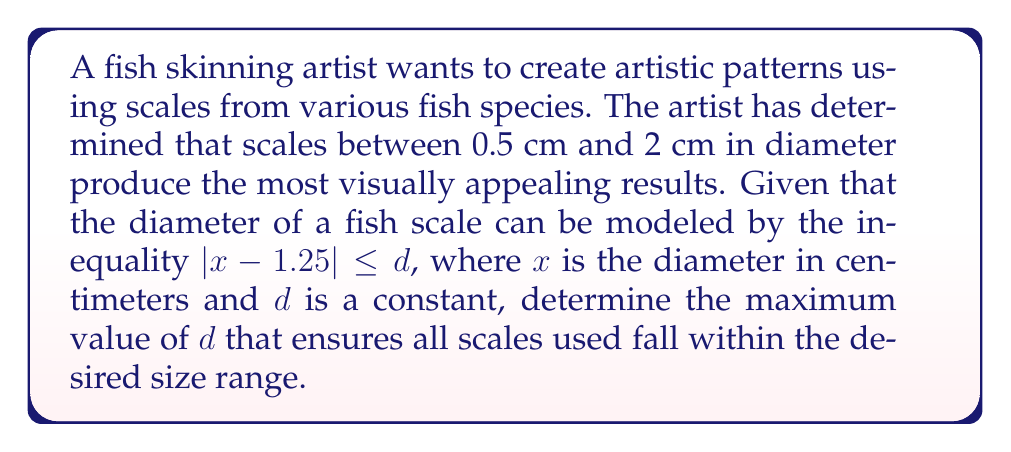Help me with this question. 1. The given inequality is $|x - 1.25| \leq d$, where $x$ is the diameter of the scale in cm.

2. The desired range for the scale diameter is between 0.5 cm and 2 cm, so:
   $0.5 \leq x \leq 2$

3. We can rewrite the original inequality as two separate inequalities:
   $-d \leq x - 1.25 \leq d$

4. Adding 1.25 to all parts of the inequality:
   $1.25 - d \leq x \leq 1.25 + d$

5. For the scales to fall within the desired range, we need:
   $1.25 - d \geq 0.5$ and $1.25 + d \leq 2$

6. From the first condition:
   $1.25 - d \geq 0.5$
   $-d \geq -0.75$
   $d \leq 0.75$

7. From the second condition:
   $1.25 + d \leq 2$
   $d \leq 0.75$

8. Both conditions result in $d \leq 0.75$, so the maximum value of $d$ is 0.75 cm.
Answer: $d = 0.75$ cm 